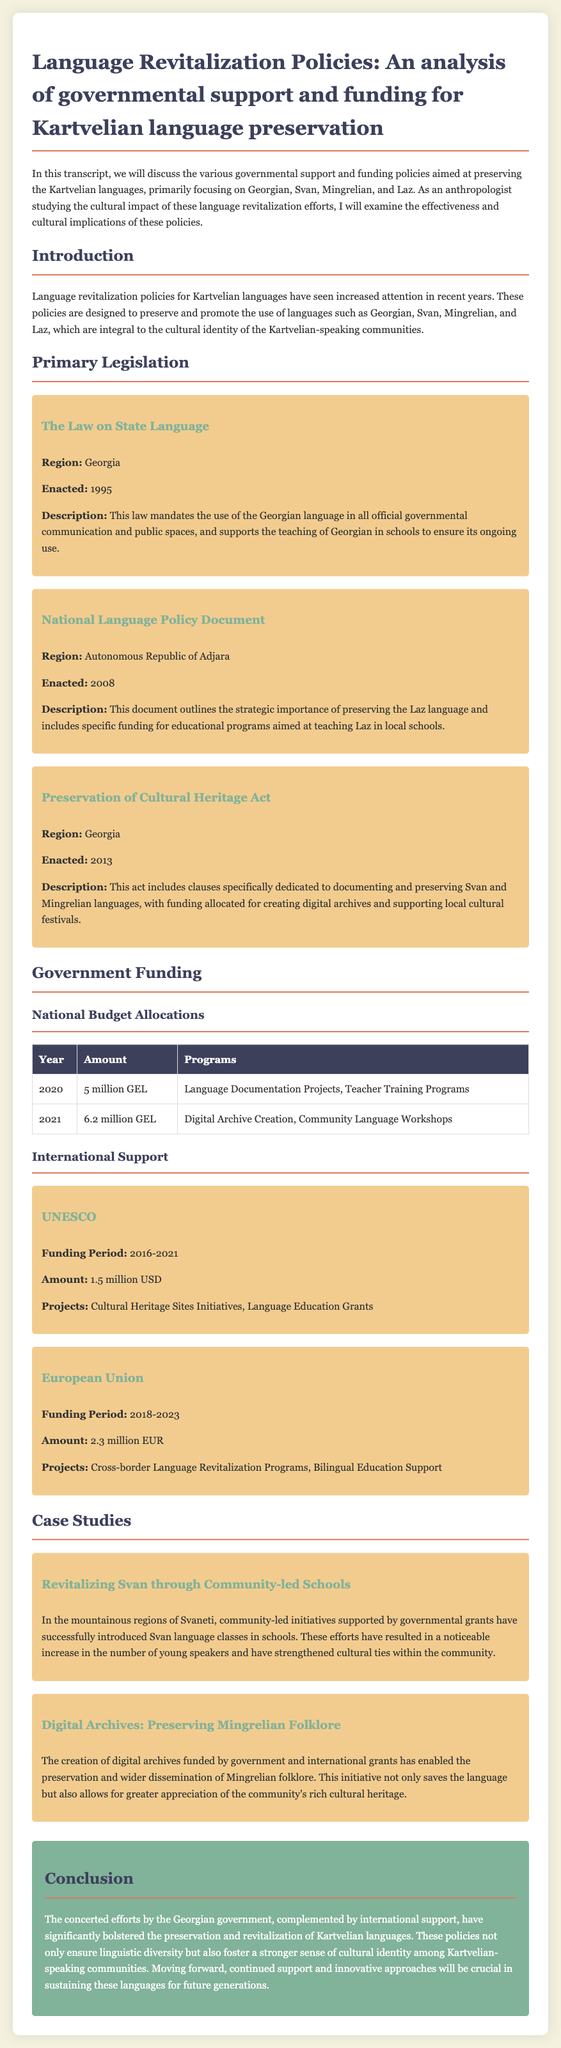What year was the Law on State Language enacted? The document mentions that the Law on State Language was enacted in 1995.
Answer: 1995 What is the allocated budget for language documentation projects in 2020? The document states that the allocated budget for language documentation projects in 2020 was 5 million GEL.
Answer: 5 million GEL What region is covered by the National Language Policy Document? The document indicates that the National Language Policy Document covers the Autonomous Republic of Adjara.
Answer: Autonomous Republic of Adjara What is the total funding amount received from UNESCO? According to the document, UNESCO provided a total funding amount of 1.5 million USD.
Answer: 1.5 million USD What are community-led initiatives in Svaneti aimed at? The document describes community-led initiatives in Svaneti as being aimed at introducing Svan language classes in schools.
Answer: Introducing Svan language classes What act includes funding for creating digital archives? The Preservation of Cultural Heritage Act includes clauses dedicated to creating digital archives.
Answer: Preservation of Cultural Heritage Act How much funding did the European Union provide for language revitalization between 2018-2023? The document states that the European Union provided 2.3 million EUR for language revitalization during that period.
Answer: 2.3 million EUR What is one cultural implication of the language revitalization policies? The document mentions that these policies foster a stronger sense of cultural identity among Kartvelian-speaking communities.
Answer: Stronger sense of cultural identity What initiatives are included under the 2021 budget allocation? The document lists Language Documentation Projects and Community Language Workshops as initiatives under the 2021 budget allocation.
Answer: Language Documentation Projects, Community Language Workshops 